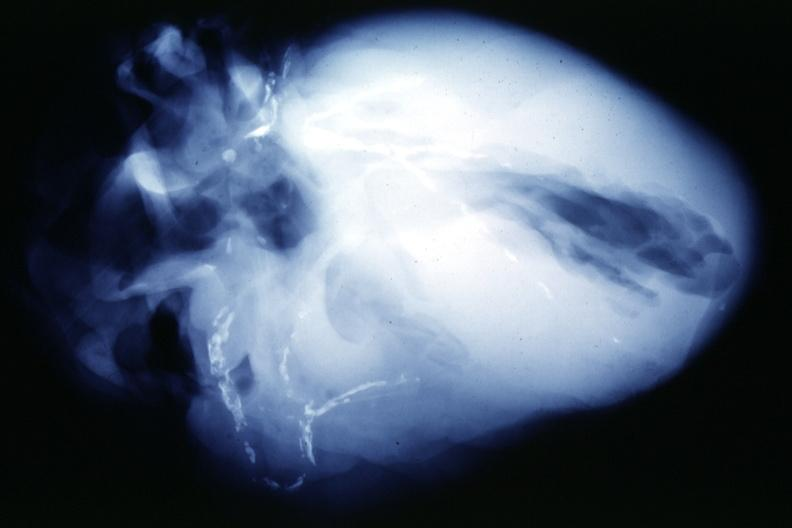s vasculature present?
Answer the question using a single word or phrase. Yes 